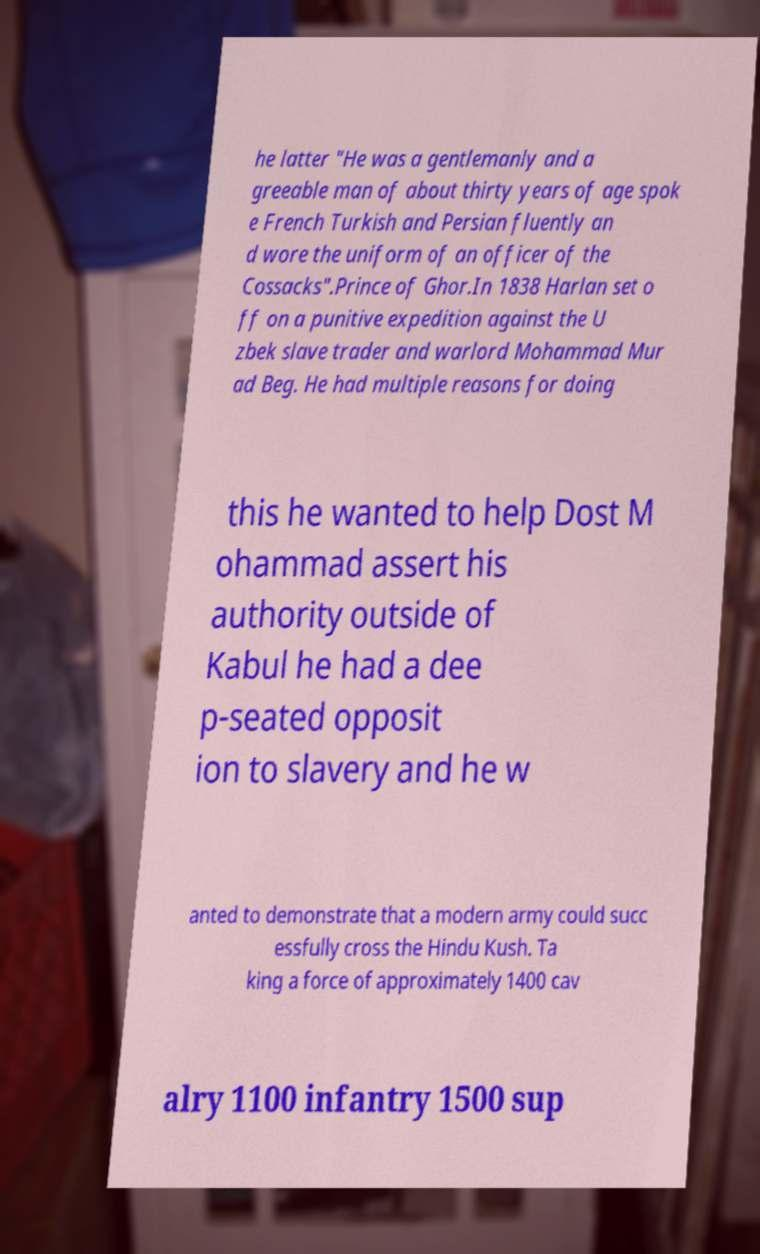I need the written content from this picture converted into text. Can you do that? he latter "He was a gentlemanly and a greeable man of about thirty years of age spok e French Turkish and Persian fluently an d wore the uniform of an officer of the Cossacks".Prince of Ghor.In 1838 Harlan set o ff on a punitive expedition against the U zbek slave trader and warlord Mohammad Mur ad Beg. He had multiple reasons for doing this he wanted to help Dost M ohammad assert his authority outside of Kabul he had a dee p-seated opposit ion to slavery and he w anted to demonstrate that a modern army could succ essfully cross the Hindu Kush. Ta king a force of approximately 1400 cav alry 1100 infantry 1500 sup 